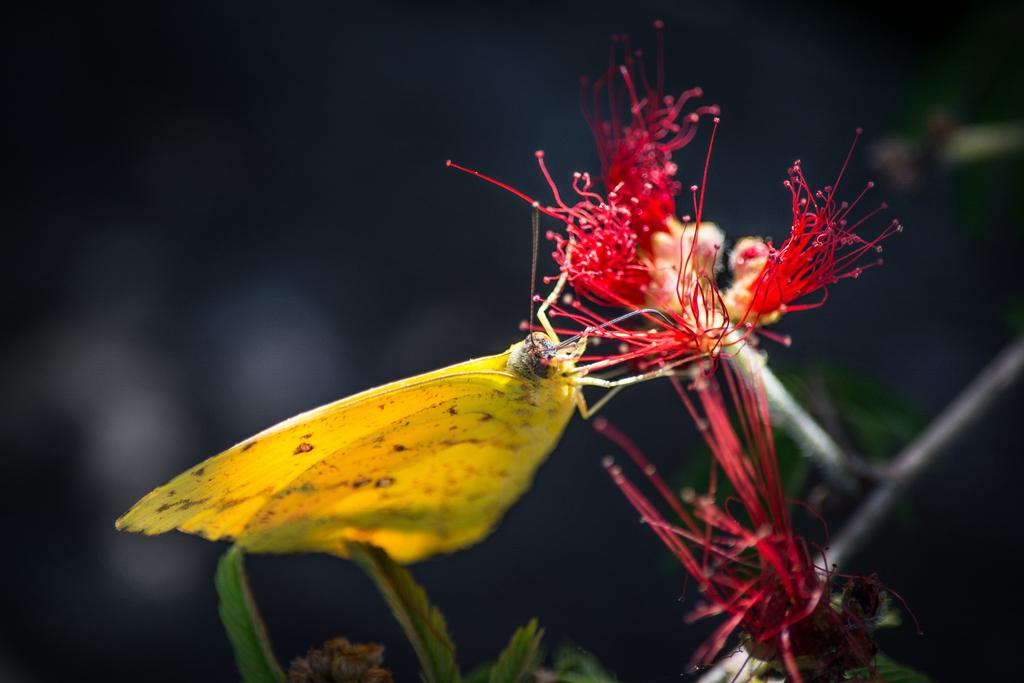What type of insect is present in the image? There is a yellow butterfly in the image. What is the butterfly resting on? The butterfly is on a red flower. What color are the leaves in the image? The leaves in the image are green. What color is the background of the image? The background of the image is black. Can you see a veil in the image? There is no veil present in the image. Are there any visible footprints in the image? There are no footprints visible in the image. 